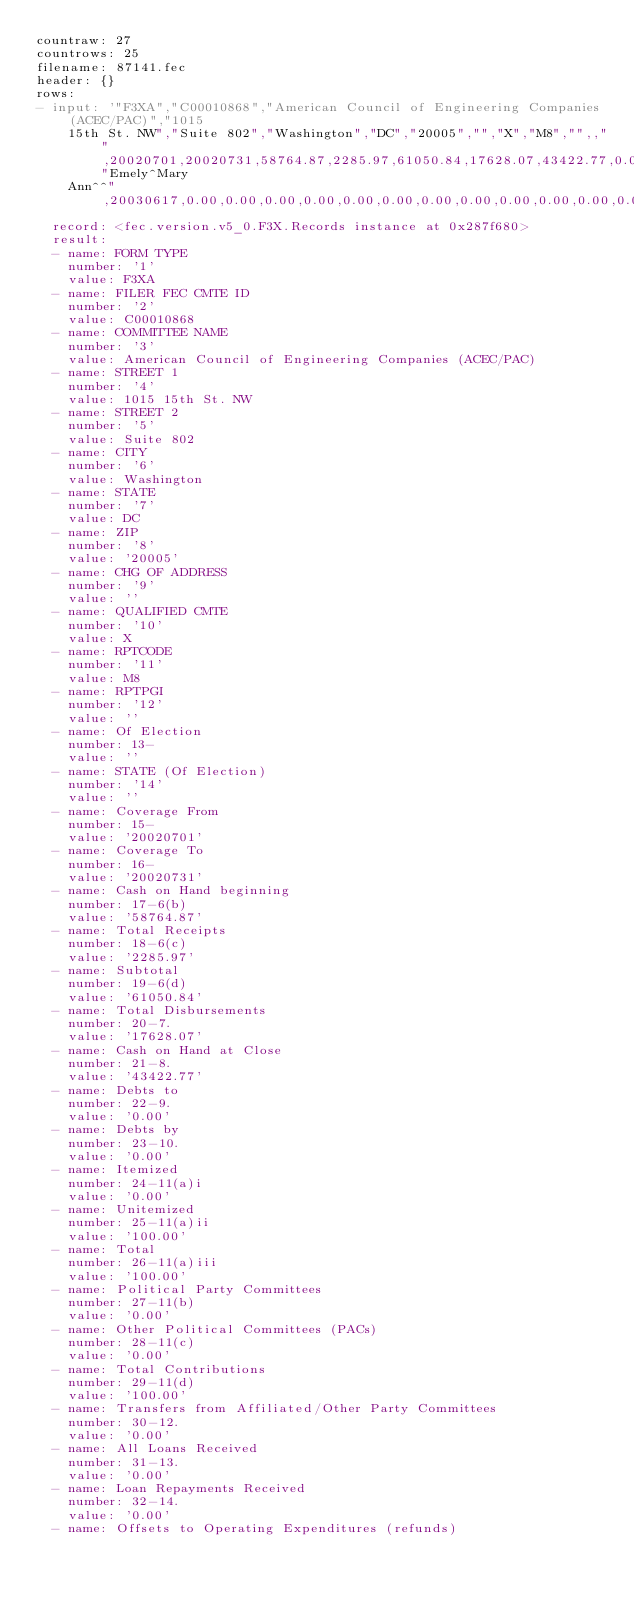Convert code to text. <code><loc_0><loc_0><loc_500><loc_500><_YAML_>countraw: 27
countrows: 25
filename: 87141.fec
header: {}
rows:
- input: '"F3XA","C00010868","American Council of Engineering Companies (ACEC/PAC)","1015
    15th St. NW","Suite 802","Washington","DC","20005","","X","M8","",,"",20020701,20020731,58764.87,2285.97,61050.84,17628.07,43422.77,0.00,0.00,0.00,100.00,100.00,0.00,0.00,100.00,0.00,0.00,0.00,0.00,0.00,2185.97,0.00,2285.97,2285.97,0.00,0.00,1728.07,1728.07,0.00,15000.00,0.00,0.00,0.00,0.00,0.00,0.00,0.00,0.00,900.00,17628.07,17628.07,100.00,0.00,100.00,1728.07,0.00,1728.07,31481.70,2002,96269.14,127750.84,84328.07,43422.77,71592.45,17424.50,89016.95,0.00,1000.00,90016.95,0.00,0.00,0.00,0.00,4066.22,2185.97,0.00,96269.14,96269.14,0.00,0.00,1728.07,1728.07,0.00,77000.00,0.00,0.00,0.00,0.00,500.00,0.00,0.00,500.00,5100.00,84328.07,84328.07,90016.95,500.00,89516.95,1728.07,0.00,1728.07,"Emely^Mary
    Ann^^",20030617,0.00,0.00,0.00,0.00,0.00,0.00,0.00,0.00,0.00,0.00,0.00,0.00'
  record: <fec.version.v5_0.F3X.Records instance at 0x287f680>
  result:
  - name: FORM TYPE
    number: '1'
    value: F3XA
  - name: FILER FEC CMTE ID
    number: '2'
    value: C00010868
  - name: COMMITTEE NAME
    number: '3'
    value: American Council of Engineering Companies (ACEC/PAC)
  - name: STREET 1
    number: '4'
    value: 1015 15th St. NW
  - name: STREET 2
    number: '5'
    value: Suite 802
  - name: CITY
    number: '6'
    value: Washington
  - name: STATE
    number: '7'
    value: DC
  - name: ZIP
    number: '8'
    value: '20005'
  - name: CHG OF ADDRESS
    number: '9'
    value: ''
  - name: QUALIFIED CMTE
    number: '10'
    value: X
  - name: RPTCODE
    number: '11'
    value: M8
  - name: RPTPGI
    number: '12'
    value: ''
  - name: Of Election
    number: 13-
    value: ''
  - name: STATE (Of Election)
    number: '14'
    value: ''
  - name: Coverage From
    number: 15-
    value: '20020701'
  - name: Coverage To
    number: 16-
    value: '20020731'
  - name: Cash on Hand beginning
    number: 17-6(b)
    value: '58764.87'
  - name: Total Receipts
    number: 18-6(c)
    value: '2285.97'
  - name: Subtotal
    number: 19-6(d)
    value: '61050.84'
  - name: Total Disbursements
    number: 20-7.
    value: '17628.07'
  - name: Cash on Hand at Close
    number: 21-8.
    value: '43422.77'
  - name: Debts to
    number: 22-9.
    value: '0.00'
  - name: Debts by
    number: 23-10.
    value: '0.00'
  - name: Itemized
    number: 24-11(a)i
    value: '0.00'
  - name: Unitemized
    number: 25-11(a)ii
    value: '100.00'
  - name: Total
    number: 26-11(a)iii
    value: '100.00'
  - name: Political Party Committees
    number: 27-11(b)
    value: '0.00'
  - name: Other Political Committees (PACs)
    number: 28-11(c)
    value: '0.00'
  - name: Total Contributions
    number: 29-11(d)
    value: '100.00'
  - name: Transfers from Affiliated/Other Party Committees
    number: 30-12.
    value: '0.00'
  - name: All Loans Received
    number: 31-13.
    value: '0.00'
  - name: Loan Repayments Received
    number: 32-14.
    value: '0.00'
  - name: Offsets to Operating Expenditures (refunds)</code> 